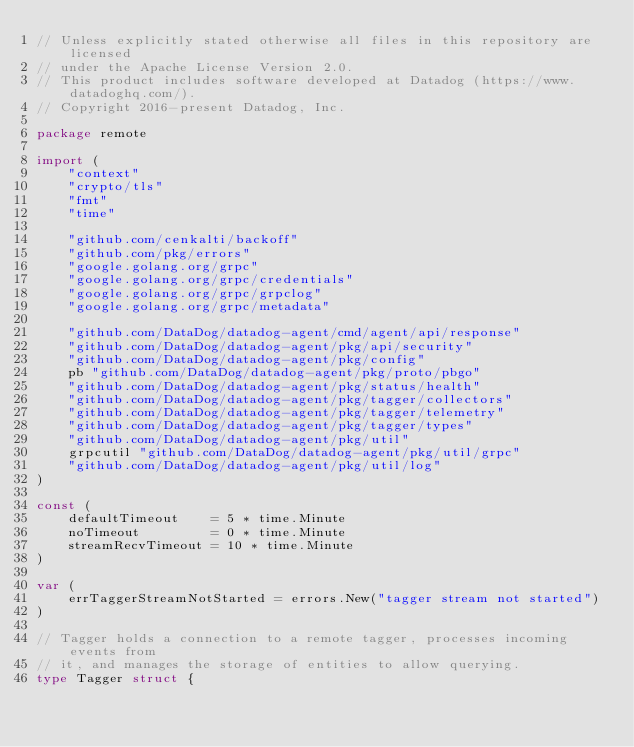<code> <loc_0><loc_0><loc_500><loc_500><_Go_>// Unless explicitly stated otherwise all files in this repository are licensed
// under the Apache License Version 2.0.
// This product includes software developed at Datadog (https://www.datadoghq.com/).
// Copyright 2016-present Datadog, Inc.

package remote

import (
	"context"
	"crypto/tls"
	"fmt"
	"time"

	"github.com/cenkalti/backoff"
	"github.com/pkg/errors"
	"google.golang.org/grpc"
	"google.golang.org/grpc/credentials"
	"google.golang.org/grpc/grpclog"
	"google.golang.org/grpc/metadata"

	"github.com/DataDog/datadog-agent/cmd/agent/api/response"
	"github.com/DataDog/datadog-agent/pkg/api/security"
	"github.com/DataDog/datadog-agent/pkg/config"
	pb "github.com/DataDog/datadog-agent/pkg/proto/pbgo"
	"github.com/DataDog/datadog-agent/pkg/status/health"
	"github.com/DataDog/datadog-agent/pkg/tagger/collectors"
	"github.com/DataDog/datadog-agent/pkg/tagger/telemetry"
	"github.com/DataDog/datadog-agent/pkg/tagger/types"
	"github.com/DataDog/datadog-agent/pkg/util"
	grpcutil "github.com/DataDog/datadog-agent/pkg/util/grpc"
	"github.com/DataDog/datadog-agent/pkg/util/log"
)

const (
	defaultTimeout    = 5 * time.Minute
	noTimeout         = 0 * time.Minute
	streamRecvTimeout = 10 * time.Minute
)

var (
	errTaggerStreamNotStarted = errors.New("tagger stream not started")
)

// Tagger holds a connection to a remote tagger, processes incoming events from
// it, and manages the storage of entities to allow querying.
type Tagger struct {</code> 